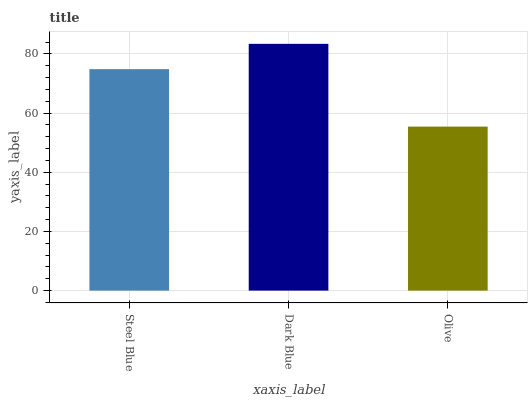Is Olive the minimum?
Answer yes or no. Yes. Is Dark Blue the maximum?
Answer yes or no. Yes. Is Dark Blue the minimum?
Answer yes or no. No. Is Olive the maximum?
Answer yes or no. No. Is Dark Blue greater than Olive?
Answer yes or no. Yes. Is Olive less than Dark Blue?
Answer yes or no. Yes. Is Olive greater than Dark Blue?
Answer yes or no. No. Is Dark Blue less than Olive?
Answer yes or no. No. Is Steel Blue the high median?
Answer yes or no. Yes. Is Steel Blue the low median?
Answer yes or no. Yes. Is Dark Blue the high median?
Answer yes or no. No. Is Olive the low median?
Answer yes or no. No. 